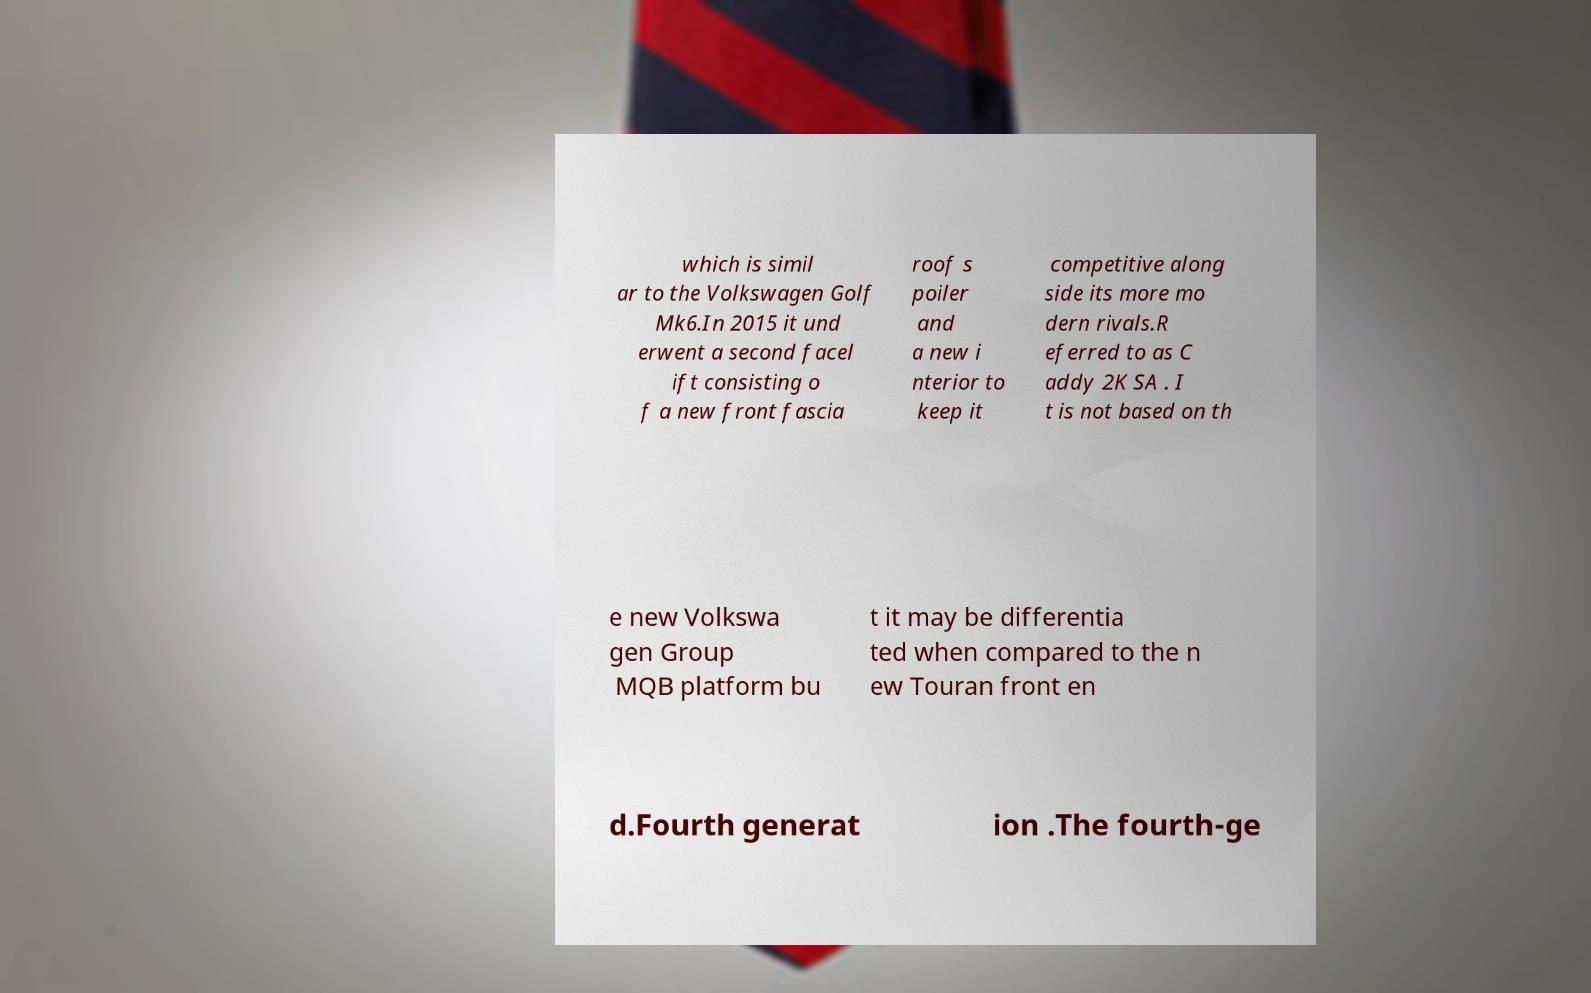Please read and relay the text visible in this image. What does it say? which is simil ar to the Volkswagen Golf Mk6.In 2015 it und erwent a second facel ift consisting o f a new front fascia roof s poiler and a new i nterior to keep it competitive along side its more mo dern rivals.R eferred to as C addy 2K SA . I t is not based on th e new Volkswa gen Group MQB platform bu t it may be differentia ted when compared to the n ew Touran front en d.Fourth generat ion .The fourth-ge 